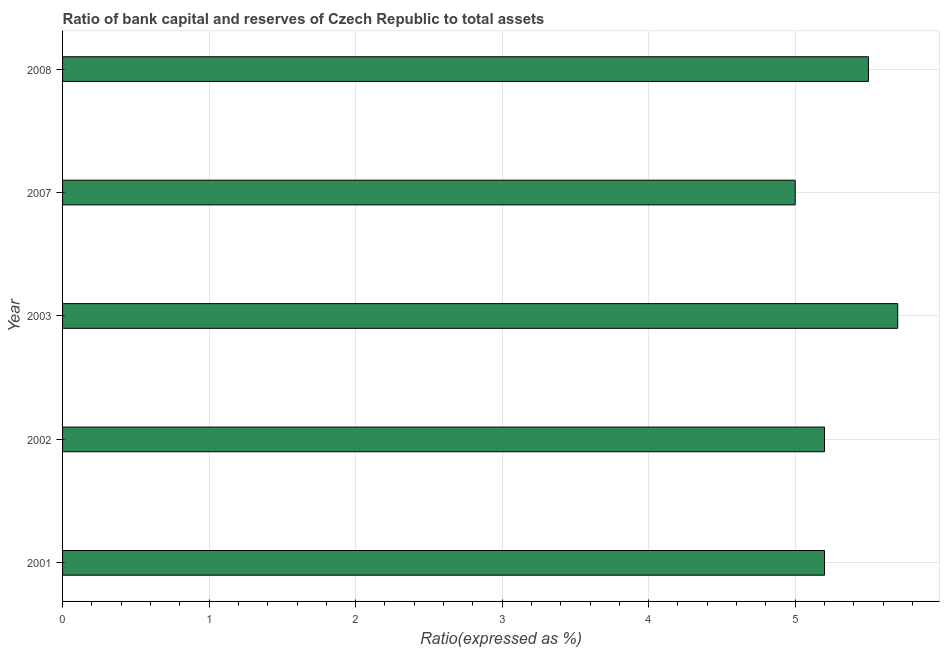Does the graph contain any zero values?
Make the answer very short. No. Does the graph contain grids?
Make the answer very short. Yes. What is the title of the graph?
Ensure brevity in your answer.  Ratio of bank capital and reserves of Czech Republic to total assets. What is the label or title of the X-axis?
Provide a short and direct response. Ratio(expressed as %). What is the bank capital to assets ratio in 2002?
Ensure brevity in your answer.  5.2. Across all years, what is the minimum bank capital to assets ratio?
Keep it short and to the point. 5. In which year was the bank capital to assets ratio maximum?
Ensure brevity in your answer.  2003. What is the sum of the bank capital to assets ratio?
Your answer should be compact. 26.6. What is the difference between the bank capital to assets ratio in 2003 and 2007?
Provide a short and direct response. 0.7. What is the average bank capital to assets ratio per year?
Offer a very short reply. 5.32. Is the bank capital to assets ratio in 2002 less than that in 2003?
Your answer should be very brief. Yes. What is the difference between the highest and the second highest bank capital to assets ratio?
Make the answer very short. 0.2. In how many years, is the bank capital to assets ratio greater than the average bank capital to assets ratio taken over all years?
Offer a very short reply. 2. Are all the bars in the graph horizontal?
Give a very brief answer. Yes. Are the values on the major ticks of X-axis written in scientific E-notation?
Offer a very short reply. No. What is the Ratio(expressed as %) of 2002?
Provide a succinct answer. 5.2. What is the Ratio(expressed as %) in 2007?
Offer a terse response. 5. What is the difference between the Ratio(expressed as %) in 2001 and 2002?
Offer a very short reply. 0. What is the difference between the Ratio(expressed as %) in 2001 and 2008?
Keep it short and to the point. -0.3. What is the difference between the Ratio(expressed as %) in 2002 and 2003?
Provide a short and direct response. -0.5. What is the difference between the Ratio(expressed as %) in 2002 and 2008?
Ensure brevity in your answer.  -0.3. What is the ratio of the Ratio(expressed as %) in 2001 to that in 2002?
Offer a terse response. 1. What is the ratio of the Ratio(expressed as %) in 2001 to that in 2003?
Provide a succinct answer. 0.91. What is the ratio of the Ratio(expressed as %) in 2001 to that in 2008?
Your answer should be very brief. 0.94. What is the ratio of the Ratio(expressed as %) in 2002 to that in 2003?
Ensure brevity in your answer.  0.91. What is the ratio of the Ratio(expressed as %) in 2002 to that in 2007?
Your response must be concise. 1.04. What is the ratio of the Ratio(expressed as %) in 2002 to that in 2008?
Give a very brief answer. 0.94. What is the ratio of the Ratio(expressed as %) in 2003 to that in 2007?
Give a very brief answer. 1.14. What is the ratio of the Ratio(expressed as %) in 2003 to that in 2008?
Your response must be concise. 1.04. What is the ratio of the Ratio(expressed as %) in 2007 to that in 2008?
Offer a terse response. 0.91. 